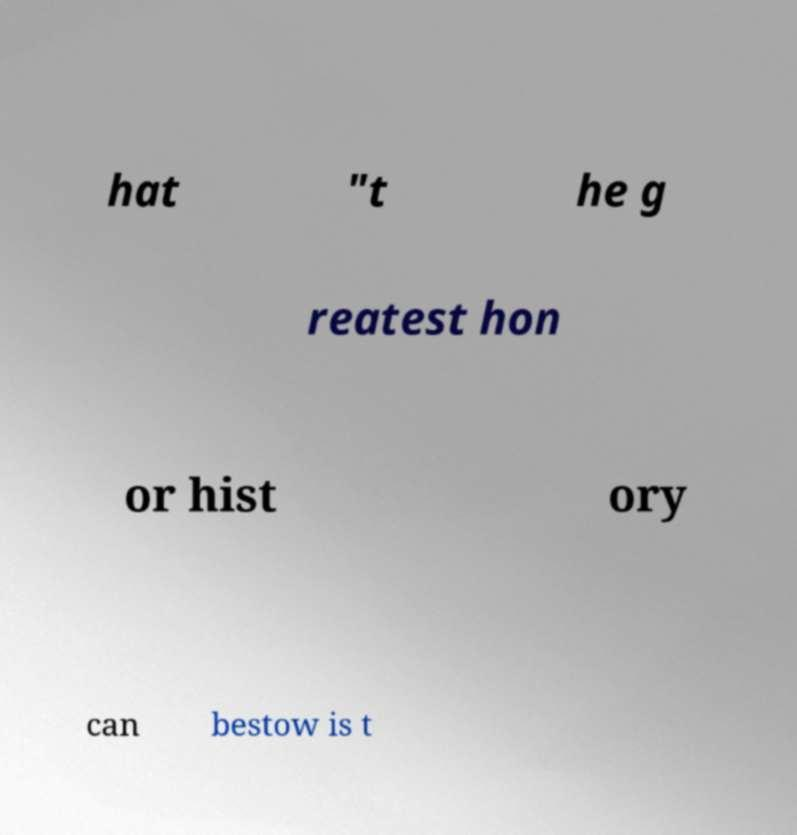There's text embedded in this image that I need extracted. Can you transcribe it verbatim? hat "t he g reatest hon or hist ory can bestow is t 